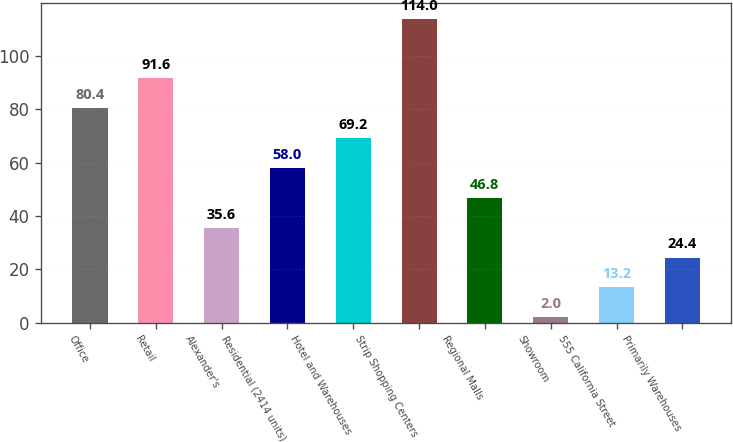<chart> <loc_0><loc_0><loc_500><loc_500><bar_chart><fcel>Office<fcel>Retail<fcel>Alexander's<fcel>Residential (2414 units)<fcel>Hotel and Warehouses<fcel>Strip Shopping Centers<fcel>Regional Malls<fcel>Showroom<fcel>555 California Street<fcel>Primarily Warehouses<nl><fcel>80.4<fcel>91.6<fcel>35.6<fcel>58<fcel>69.2<fcel>114<fcel>46.8<fcel>2<fcel>13.2<fcel>24.4<nl></chart> 